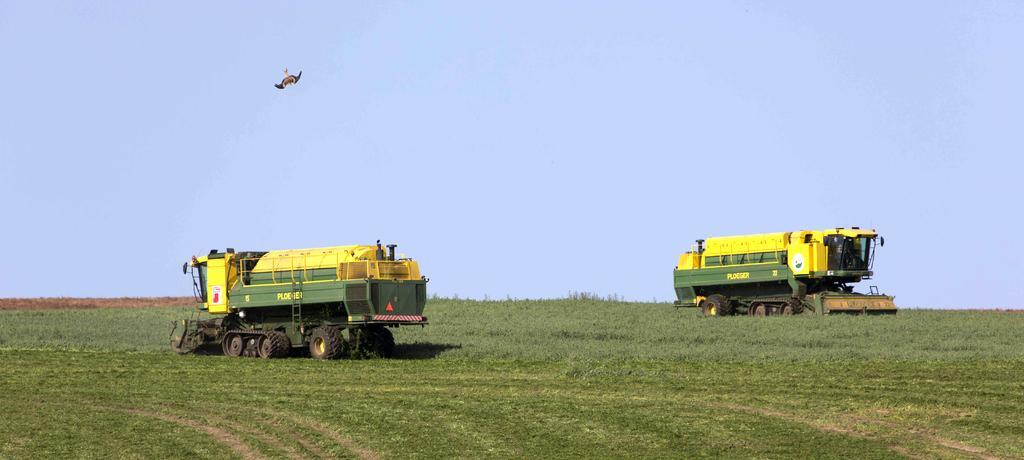Could you give a brief overview of what you see in this image? In this picture we can see the field vehicles on the farmland. In the top left there is an eagle. At the top there is a sky. At the bottom we can see the grass. 